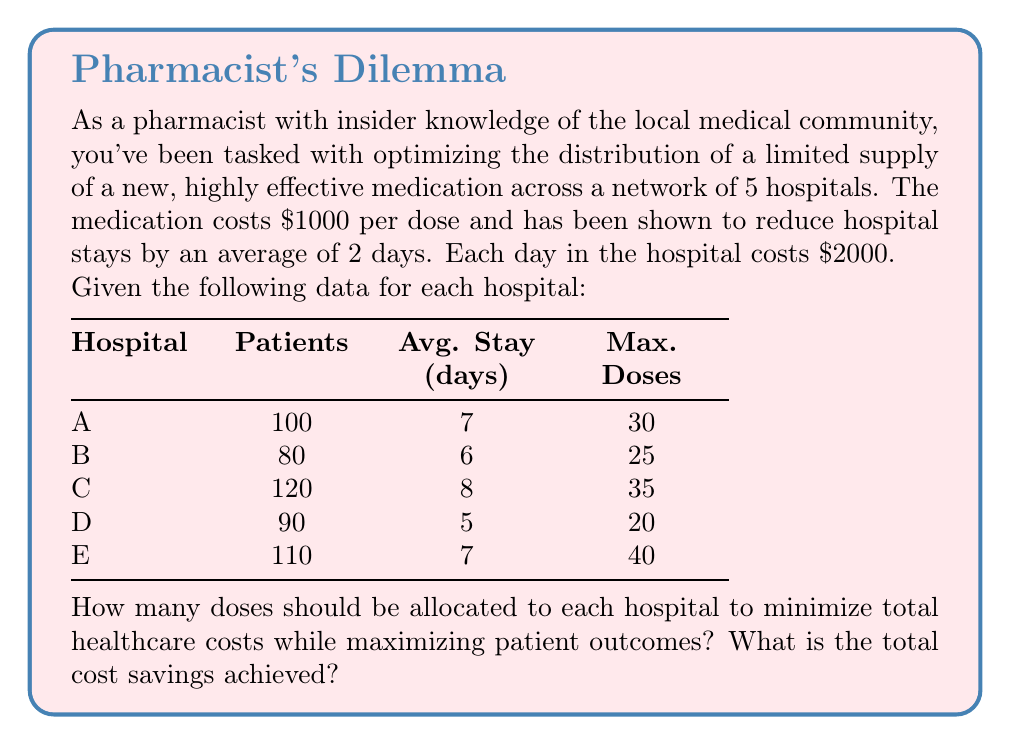What is the answer to this math problem? Let's approach this step-by-step:

1) First, we need to calculate the potential savings per dose for each hospital:
   Savings per dose = (2 days * $2000/day) - $1000 = $3000

2) Now, let's calculate the maximum potential savings for each hospital:
   Hospital A: 30 * $3000 = $90,000
   Hospital B: 25 * $3000 = $75,000
   Hospital C: 35 * $3000 = $105,000
   Hospital D: 20 * $3000 = $60,000
   Hospital E: 40 * $3000 = $120,000

3) The optimal strategy is to allocate doses to the hospitals with the highest potential savings first, up to their maximum capacity.

4) Total doses available = 30 + 25 + 35 + 20 + 40 = 150

5) Allocating doses in order of highest potential savings:
   Hospital E: 40 doses
   Hospital C: 35 doses
   Hospital A: 30 doses
   Hospital B: 25 doses
   Hospital D: 20 doses

6) This allocation uses all 150 doses and maximizes the total savings.

7) Calculate total savings:
   $$ \text{Total Savings} = (40 + 35 + 30 + 25 + 20) * \$3000 = 150 * \$3000 = \$450,000 $$

Therefore, the optimal allocation is to give each hospital its maximum number of doses, and the total cost savings achieved is $450,000.
Answer: Hospital E: 40, C: 35, A: 30, B: 25, D: 20; Total savings: $450,000 